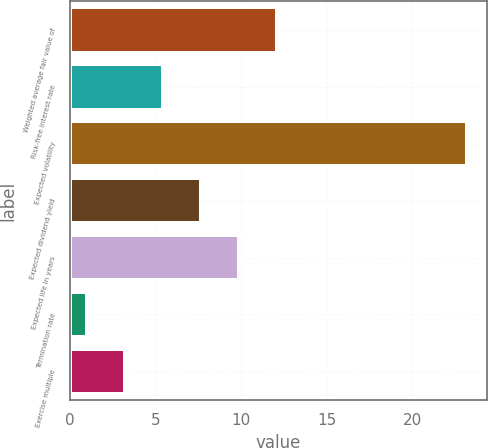Convert chart to OTSL. <chart><loc_0><loc_0><loc_500><loc_500><bar_chart><fcel>Weighted average fair value of<fcel>Risk-free interest rate<fcel>Expected volatility<fcel>Expected dividend yield<fcel>Expected life in years<fcel>Termination rate<fcel>Exercise multiple<nl><fcel>12.09<fcel>5.43<fcel>23.2<fcel>7.65<fcel>9.87<fcel>0.99<fcel>3.21<nl></chart> 